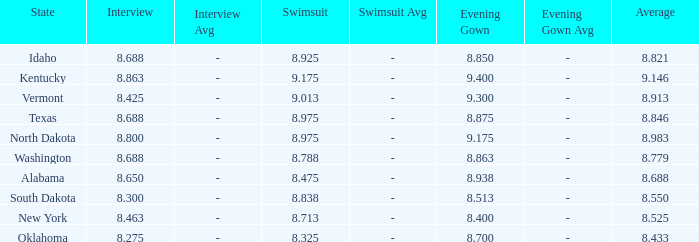What is the lowest evening score of the contestant with an evening gown less than 8.938, from Texas, and with an average less than 8.846 has? None. 